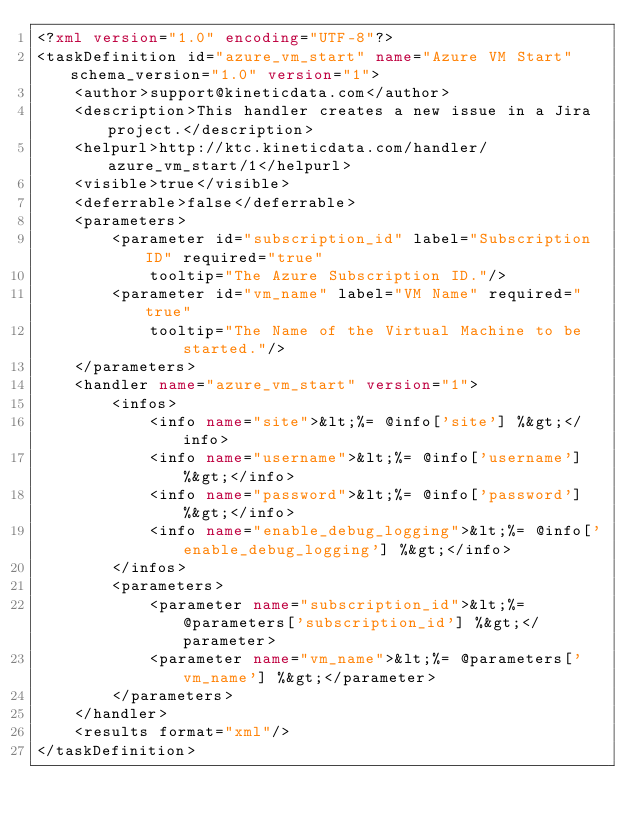<code> <loc_0><loc_0><loc_500><loc_500><_XML_><?xml version="1.0" encoding="UTF-8"?>
<taskDefinition id="azure_vm_start" name="Azure VM Start" schema_version="1.0" version="1">
    <author>support@kineticdata.com</author>
    <description>This handler creates a new issue in a Jira project.</description>
    <helpurl>http://ktc.kineticdata.com/handler/azure_vm_start/1</helpurl>
    <visible>true</visible>
    <deferrable>false</deferrable>
    <parameters>
        <parameter id="subscription_id" label="Subscription ID" required="true"
            tooltip="The Azure Subscription ID."/>
        <parameter id="vm_name" label="VM Name" required="true"
            tooltip="The Name of the Virtual Machine to be started."/>
    </parameters>
    <handler name="azure_vm_start" version="1">
        <infos>
            <info name="site">&lt;%= @info['site'] %&gt;</info>
            <info name="username">&lt;%= @info['username'] %&gt;</info>
            <info name="password">&lt;%= @info['password'] %&gt;</info>
            <info name="enable_debug_logging">&lt;%= @info['enable_debug_logging'] %&gt;</info>
        </infos>
        <parameters>
            <parameter name="subscription_id">&lt;%= @parameters['subscription_id'] %&gt;</parameter>
            <parameter name="vm_name">&lt;%= @parameters['vm_name'] %&gt;</parameter>
        </parameters>
    </handler>
    <results format="xml"/>
</taskDefinition>
</code> 